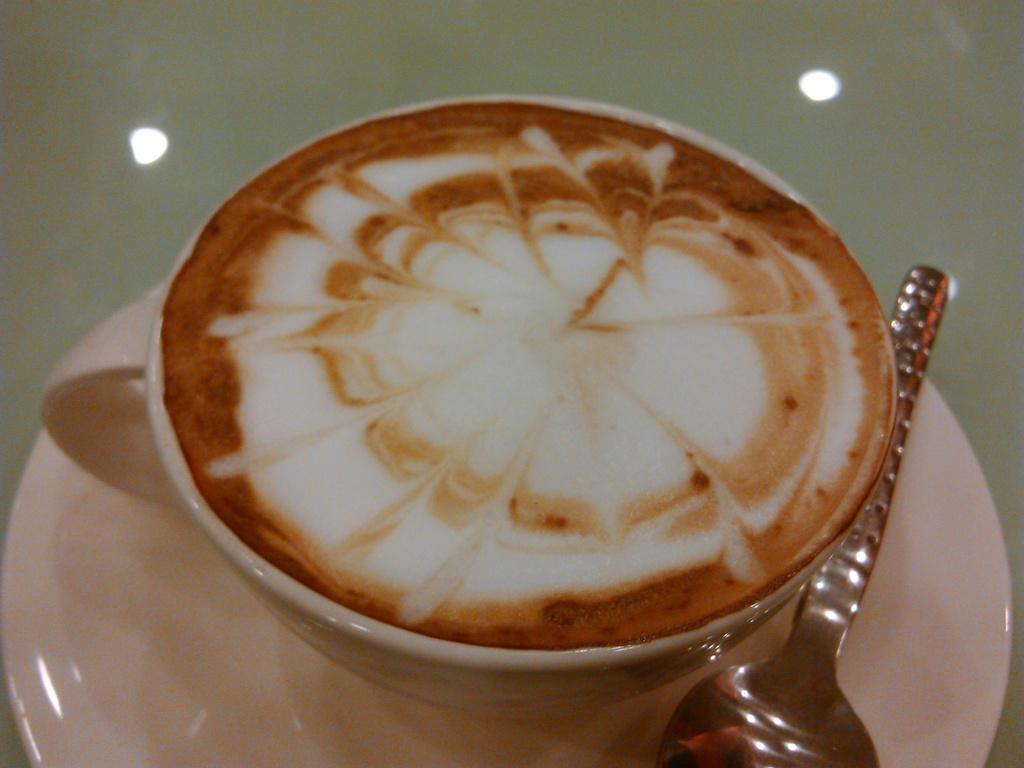Please provide a concise description of this image. In this image I can see the cup on the saucer and I can also see the spoon and I can see some liquid in white and brown color in the cup. 